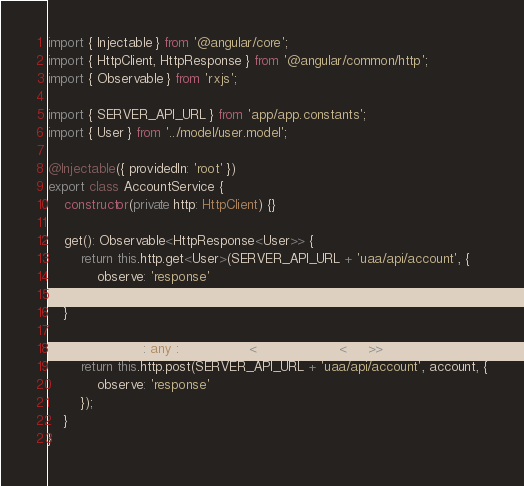Convert code to text. <code><loc_0><loc_0><loc_500><loc_500><_TypeScript_>import { Injectable } from '@angular/core';
import { HttpClient, HttpResponse } from '@angular/common/http';
import { Observable } from 'rxjs';

import { SERVER_API_URL } from 'app/app.constants';
import { User } from '../model/user.model';

@Injectable({ providedIn: 'root' })
export class AccountService {
    constructor(private http: HttpClient) {}

    get(): Observable<HttpResponse<User>> {
        return this.http.get<User>(SERVER_API_URL + 'uaa/api/account', {
            observe: 'response'
        });
    }

    save(account: any): Observable<HttpResponse<any>> {
        return this.http.post(SERVER_API_URL + 'uaa/api/account', account, {
            observe: 'response'
        });
    }
}
</code> 